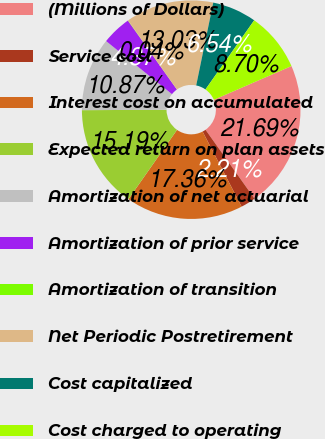<chart> <loc_0><loc_0><loc_500><loc_500><pie_chart><fcel>(Millions of Dollars)<fcel>Service cost<fcel>Interest cost on accumulated<fcel>Expected return on plan assets<fcel>Amortization of net actuarial<fcel>Amortization of prior service<fcel>Amortization of transition<fcel>Net Periodic Postretirement<fcel>Cost capitalized<fcel>Cost charged to operating<nl><fcel>21.69%<fcel>2.21%<fcel>17.36%<fcel>15.19%<fcel>10.87%<fcel>4.37%<fcel>0.04%<fcel>13.03%<fcel>6.54%<fcel>8.7%<nl></chart> 